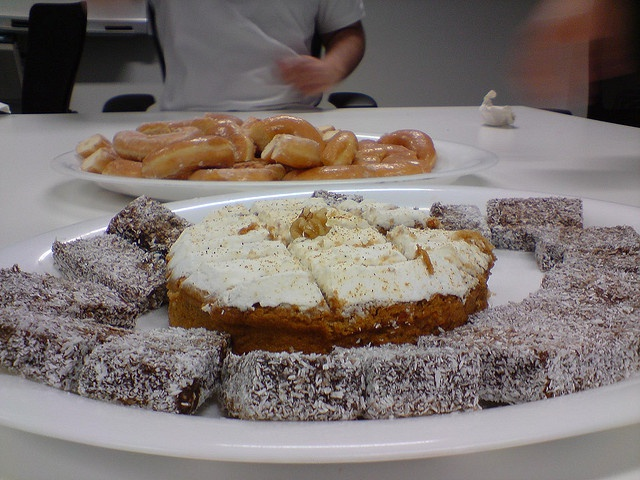Describe the objects in this image and their specific colors. I can see cake in gray, darkgray, maroon, lightgray, and black tones, dining table in gray, darkgray, and black tones, cake in gray, darkgray, and black tones, people in gray, black, maroon, and brown tones, and cake in gray, darkgray, black, and maroon tones in this image. 